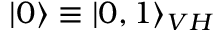<formula> <loc_0><loc_0><loc_500><loc_500>| 0 \rangle \equiv | 0 , 1 \rangle _ { V H }</formula> 